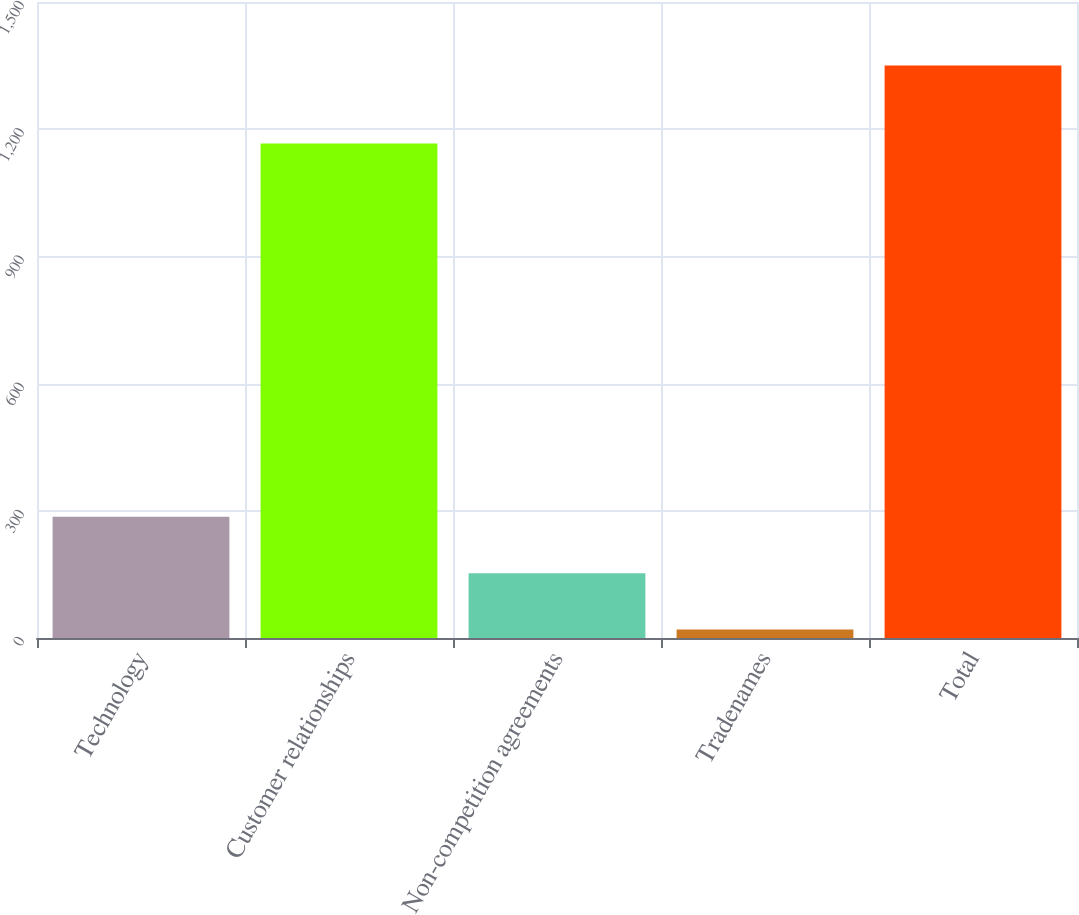Convert chart. <chart><loc_0><loc_0><loc_500><loc_500><bar_chart><fcel>Technology<fcel>Customer relationships<fcel>Non-competition agreements<fcel>Tradenames<fcel>Total<nl><fcel>286<fcel>1166<fcel>153<fcel>20<fcel>1350<nl></chart> 